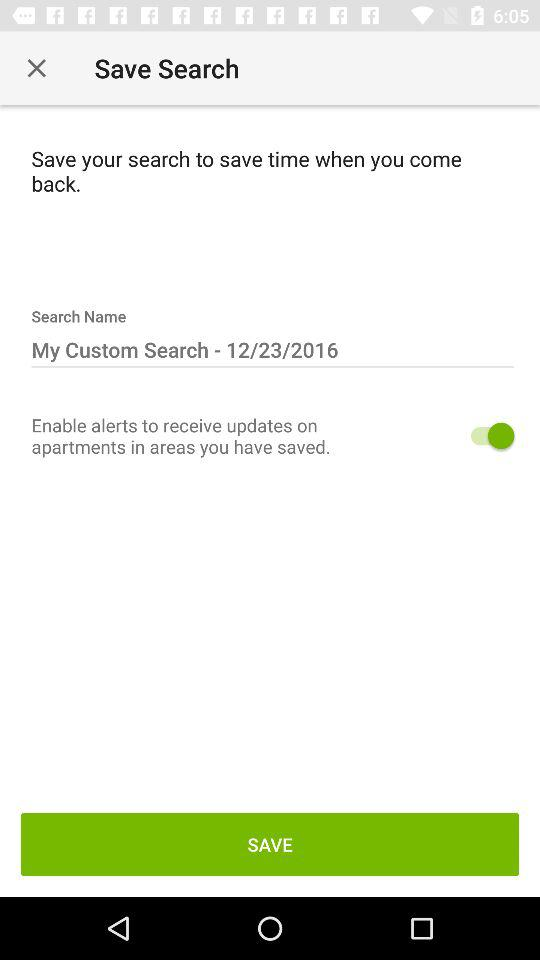What is the search name? The search name is "My Custom Search - 12/23/2016". 